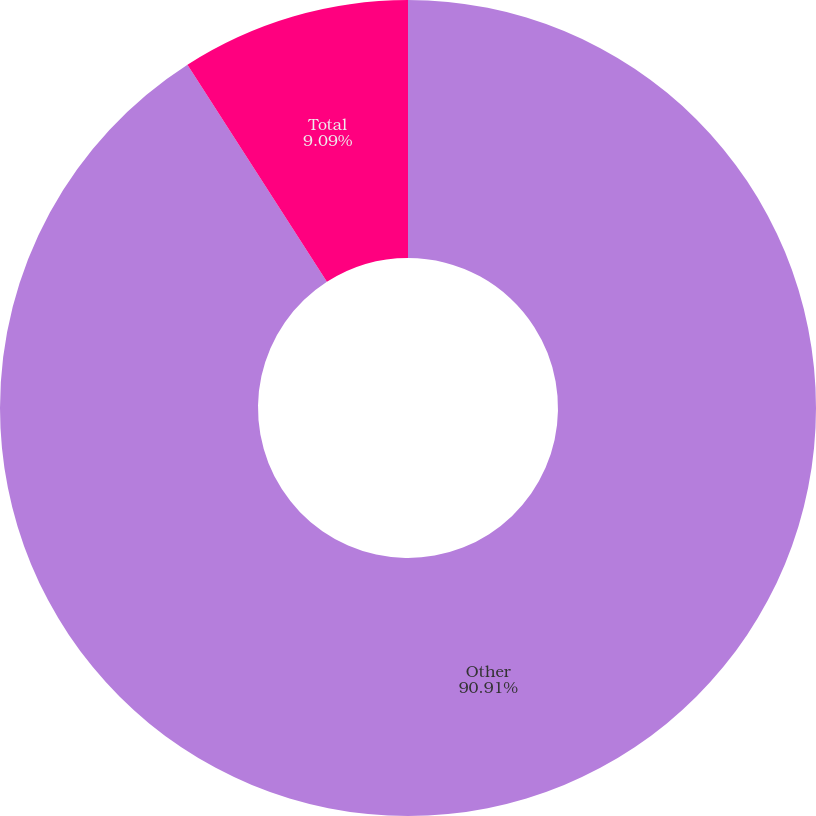<chart> <loc_0><loc_0><loc_500><loc_500><pie_chart><fcel>Other<fcel>All other membership<fcel>Total<nl><fcel>90.91%<fcel>0.0%<fcel>9.09%<nl></chart> 